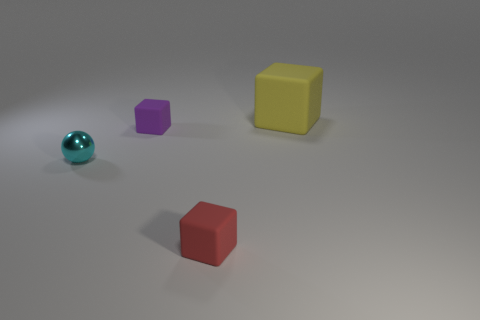How many rubber objects are behind the small cyan object and in front of the shiny sphere?
Your answer should be very brief. 0. How many red objects are either shiny balls or matte cylinders?
Ensure brevity in your answer.  0. What number of metal things are small purple balls or tiny purple things?
Make the answer very short. 0. Are any small gray metallic blocks visible?
Provide a succinct answer. No. Is the small red object the same shape as the yellow object?
Keep it short and to the point. Yes. There is a rubber object behind the rubber thing that is on the left side of the red rubber thing; what number of tiny cubes are in front of it?
Make the answer very short. 2. The thing that is both behind the cyan ball and in front of the large thing is made of what material?
Offer a terse response. Rubber. The tiny object that is both in front of the purple rubber object and right of the tiny sphere is what color?
Give a very brief answer. Red. Are there any other things that have the same color as the small metallic ball?
Provide a short and direct response. No. What shape is the thing behind the small cube behind the tiny rubber object in front of the tiny cyan metal sphere?
Make the answer very short. Cube. 